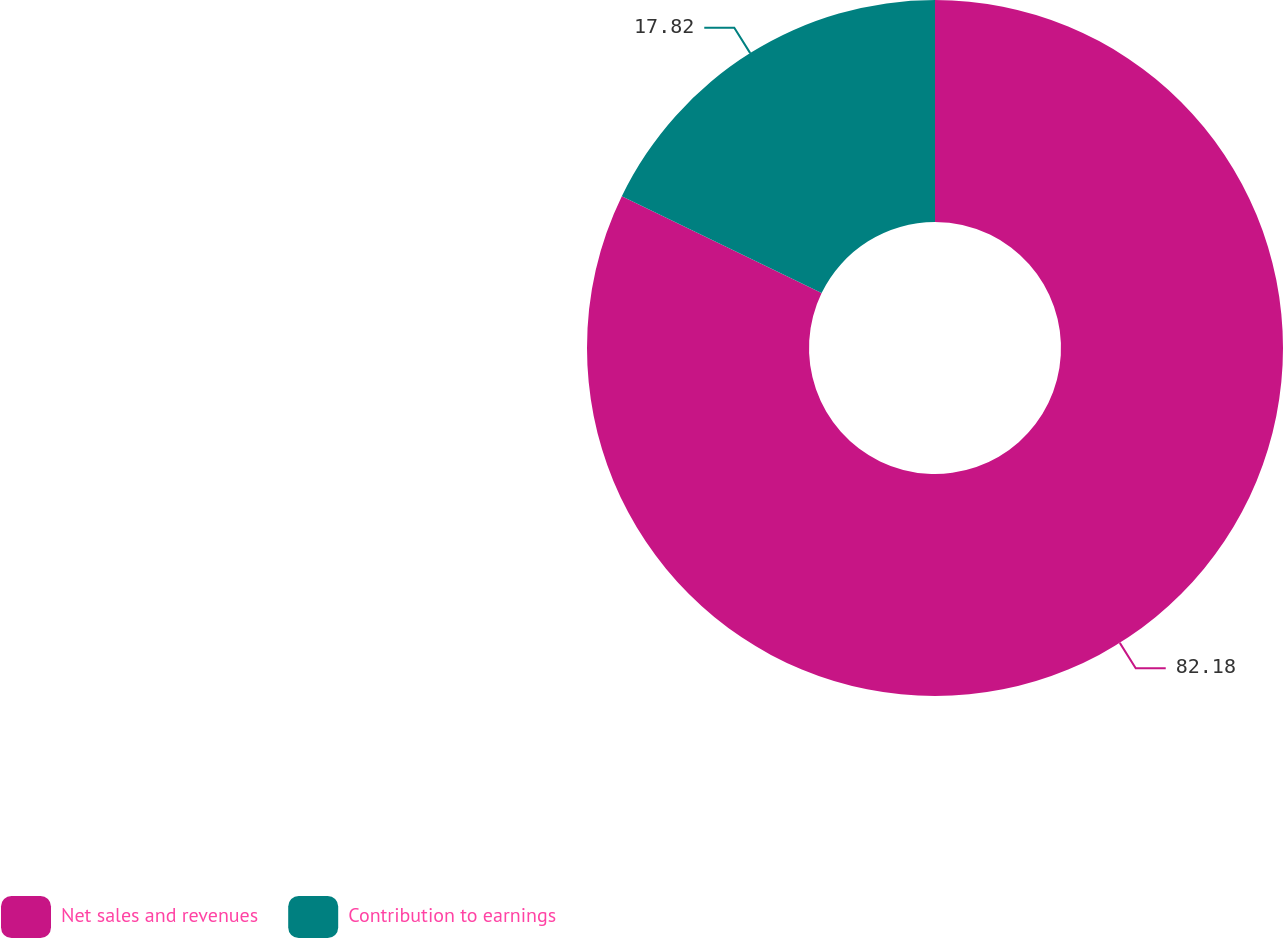Convert chart. <chart><loc_0><loc_0><loc_500><loc_500><pie_chart><fcel>Net sales and revenues<fcel>Contribution to earnings<nl><fcel>82.18%<fcel>17.82%<nl></chart> 